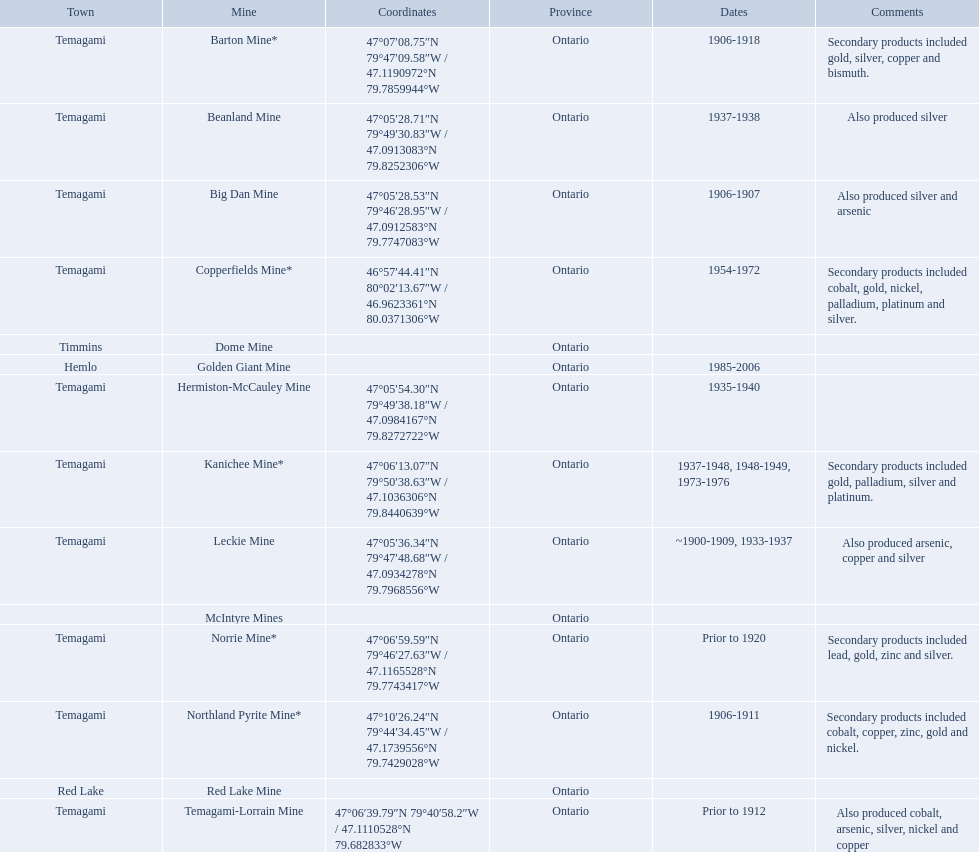What dates was the golden giant mine open? 1985-2006. What dates was the beanland mine open? 1937-1938. Of those mines, which was open longer? Golden Giant Mine. 